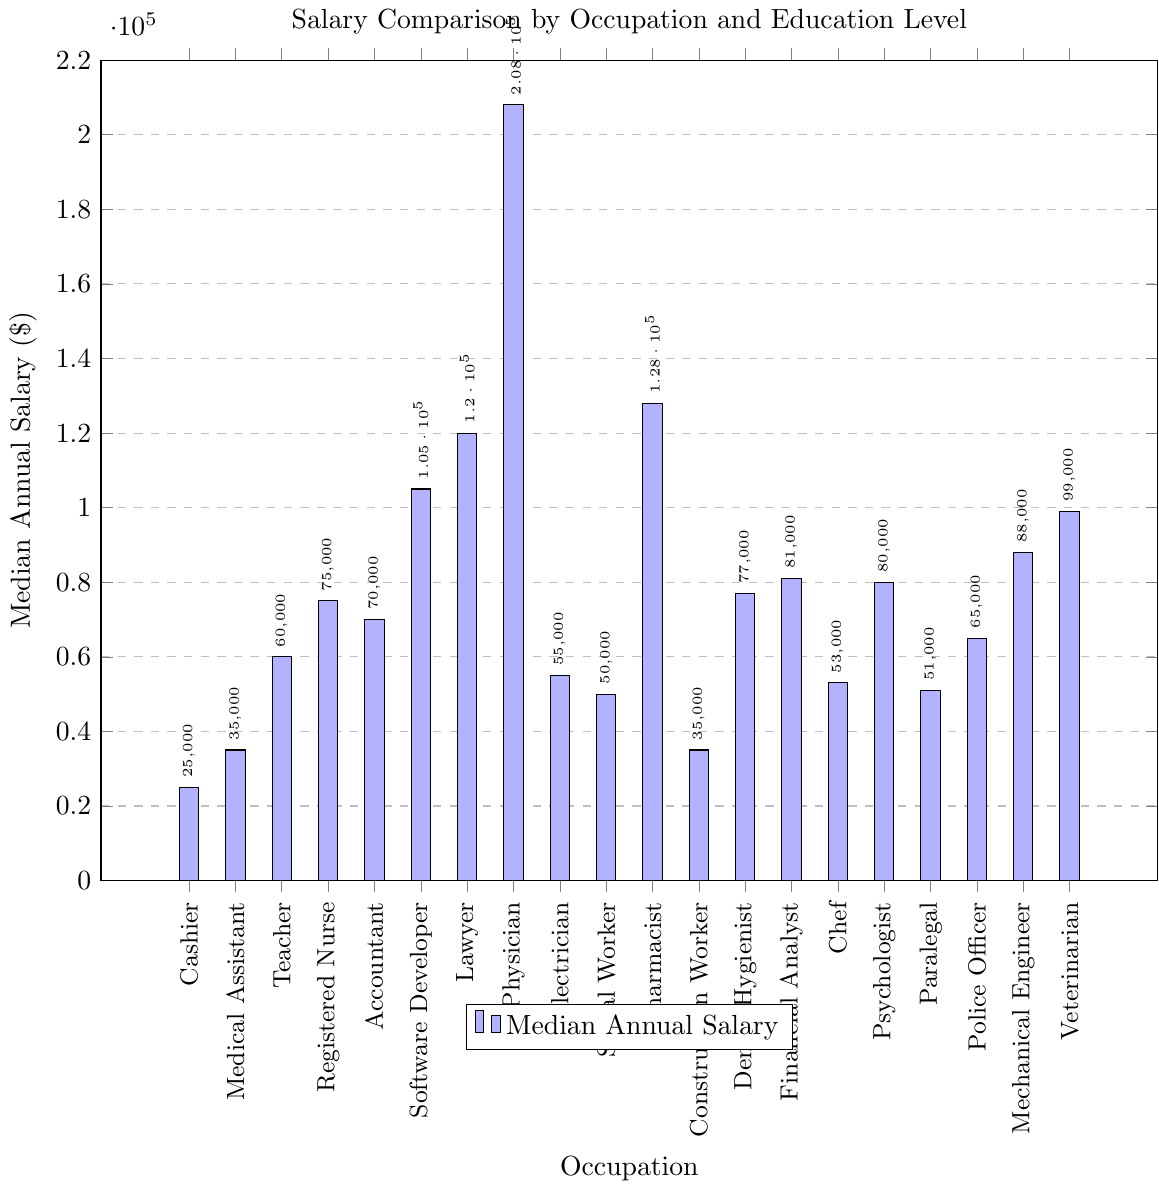What is the median annual salary for a Software Developer? The bar labeled "Software Developer" indicates the median annual salary. The height of this bar corresponds to a value.
Answer: 105000 Which occupation requires a Doctoral Degree and has the highest median salary? To find this, identify the bars for occupations that require a "Doctoral Degree" and compare their heights. The tallest one represents the highest salary.
Answer: Physician Which occupation has a higher median salary: Accountant or Police Officer? Look at the bars for "Accountant" and "Police Officer" and compare their heights. The taller bar indicates the profession with a higher salary.
Answer: Accountant What is the difference in median annual salary between a Cashier and a Pharmacist? Identify the bars for "Cashier" and "Pharmacist," then subtract the value of the Cashier's bar from the Pharmacist's bar.
Answer: 103000 What is the average median annual salary for occupations requiring an Associate's Degree? Identify all bars for occupations with an "Associate's Degree," add their values, and divide by the number of such occupations.
Answer: (35000 + 77000 + 51000 + 65000) / 4 = 57000 Which occupation has the lowest median annual salary? To find the lowest salary, look for the shortest bar in the chart.
Answer: Cashier Is the median salary of a Registered Nurse greater than that of a Financial Analyst? Compare the heights of the bars for "Registered Nurse" and "Financial Analyst." If the Registered Nurse's bar is taller, the salary is greater.
Answer: No Which occupation that requires a Bachelor's Degree has the highest median salary? Among the bars labeled with a "Bachelor's Degree," identify the tallest one.
Answer: Software Developer What is the median salary difference between a Lawyer and a Teacher? Identify the bars for "Lawyer" and "Teacher" and subtract the Teacher's salary value from the Lawyer's.
Answer: 60000 What is the combined median annual salary of a Chef and an Electrician? Add the values of the bars labeled "Chef" and "Electrician."
Answer: 53000 + 55000 = 108000 